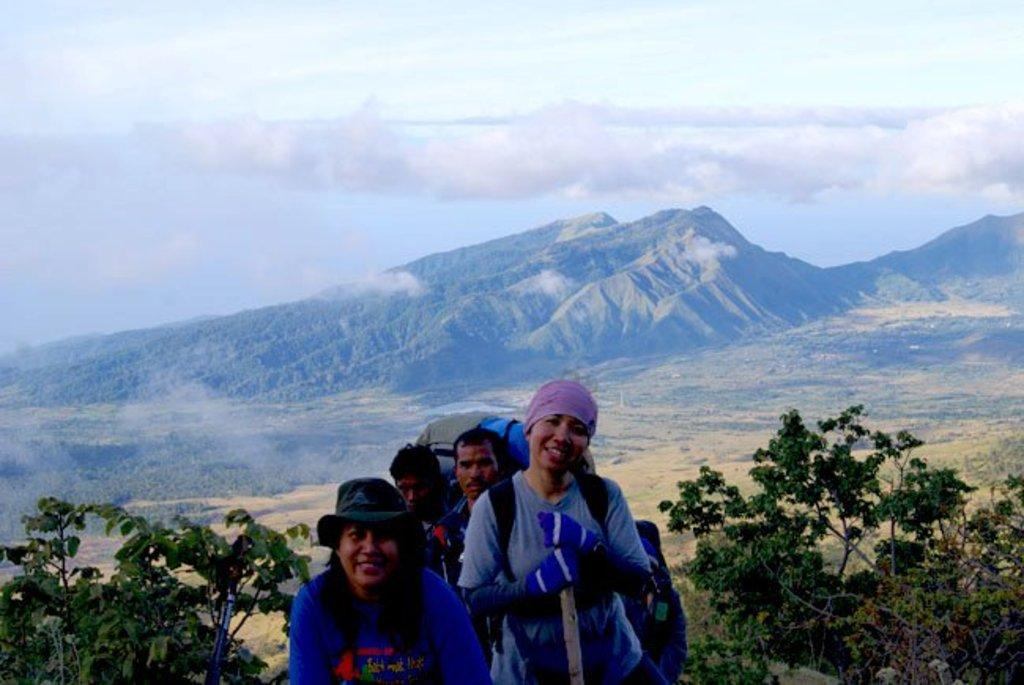How many people are in the image? There are four persons in the image. What else can be seen in the image besides the people? There are plants, trees, mountains, smoke, fog, and the sky visible in the image. Can you describe the natural environment in the image? The image features plants, trees, mountains, smoke, and fog, which are all part of the natural environment. What is visible in the background of the image? In the background of the image, there are mountains, smoke, fog, and the sky. What type of oven can be seen in the image? There is no oven present in the image. Can you describe the bee's activity in the image? There are no bees present in the image. 